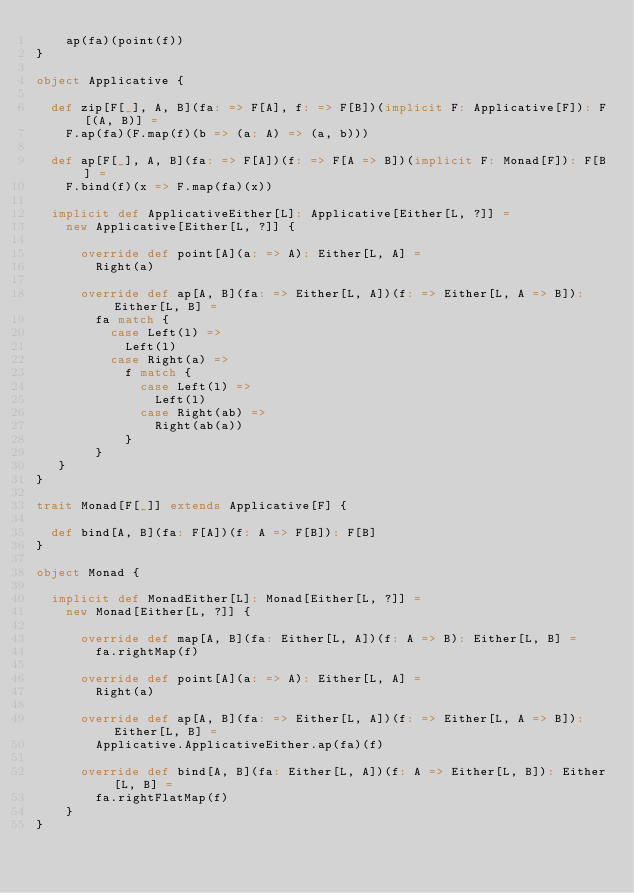<code> <loc_0><loc_0><loc_500><loc_500><_Scala_>    ap(fa)(point(f))
}

object Applicative {

  def zip[F[_], A, B](fa: => F[A], f: => F[B])(implicit F: Applicative[F]): F[(A, B)] =
    F.ap(fa)(F.map(f)(b => (a: A) => (a, b)))

  def ap[F[_], A, B](fa: => F[A])(f: => F[A => B])(implicit F: Monad[F]): F[B] =
    F.bind(f)(x => F.map(fa)(x))

  implicit def ApplicativeEither[L]: Applicative[Either[L, ?]] =
    new Applicative[Either[L, ?]] {

      override def point[A](a: => A): Either[L, A] =
        Right(a)

      override def ap[A, B](fa: => Either[L, A])(f: => Either[L, A => B]): Either[L, B] =
        fa match {
          case Left(l) =>
            Left(l)
          case Right(a) =>
            f match {
              case Left(l) =>
                Left(l)
              case Right(ab) =>
                Right(ab(a))
            }
        }
   }
}

trait Monad[F[_]] extends Applicative[F] {

  def bind[A, B](fa: F[A])(f: A => F[B]): F[B]
}

object Monad {

  implicit def MonadEither[L]: Monad[Either[L, ?]] =
    new Monad[Either[L, ?]] {

      override def map[A, B](fa: Either[L, A])(f: A => B): Either[L, B] =
        fa.rightMap(f)

      override def point[A](a: => A): Either[L, A] =
        Right(a)

      override def ap[A, B](fa: => Either[L, A])(f: => Either[L, A => B]): Either[L, B] =
        Applicative.ApplicativeEither.ap(fa)(f)

      override def bind[A, B](fa: Either[L, A])(f: A => Either[L, B]): Either[L, B] =
        fa.rightFlatMap(f)
    }
}
</code> 